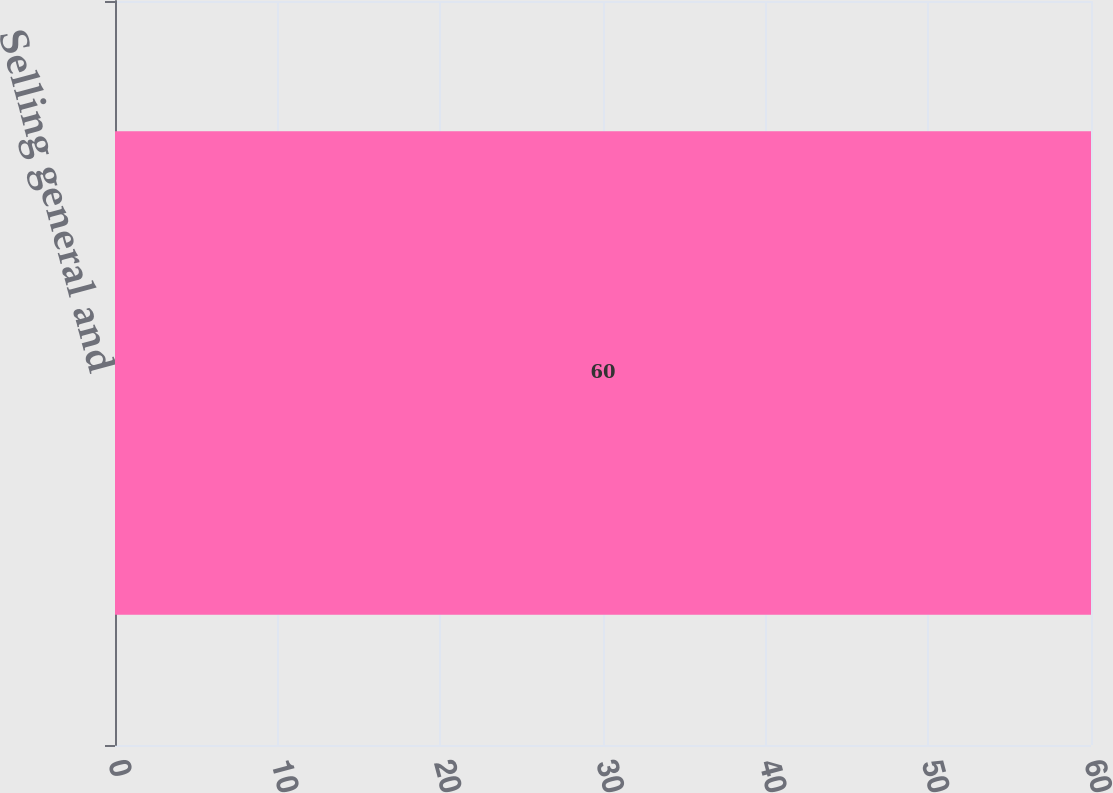<chart> <loc_0><loc_0><loc_500><loc_500><bar_chart><fcel>Selling general and<nl><fcel>60<nl></chart> 